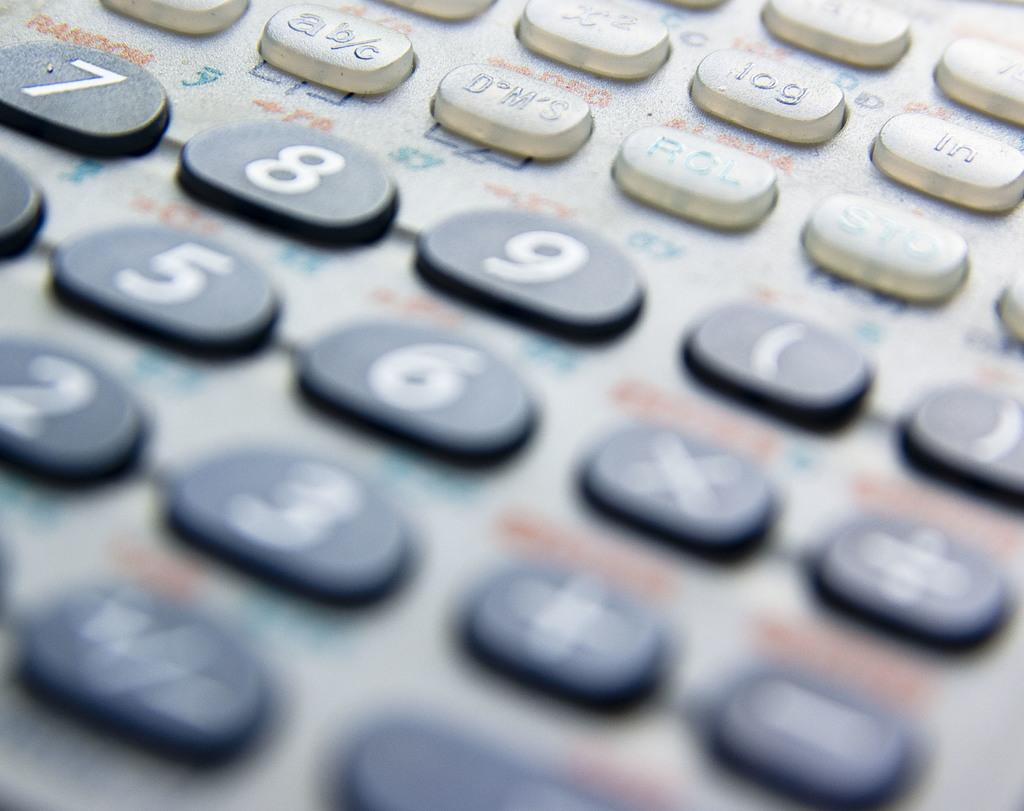Provide a one-sentence caption for the provided image. A calculator contains a number of keys including digits such as 7. 